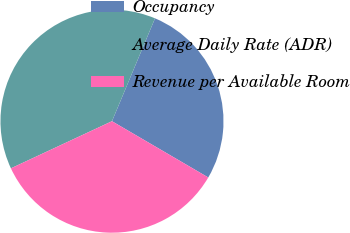Convert chart to OTSL. <chart><loc_0><loc_0><loc_500><loc_500><pie_chart><fcel>Occupancy<fcel>Average Daily Rate (ADR)<fcel>Revenue per Available Room<nl><fcel>27.11%<fcel>38.25%<fcel>34.64%<nl></chart> 